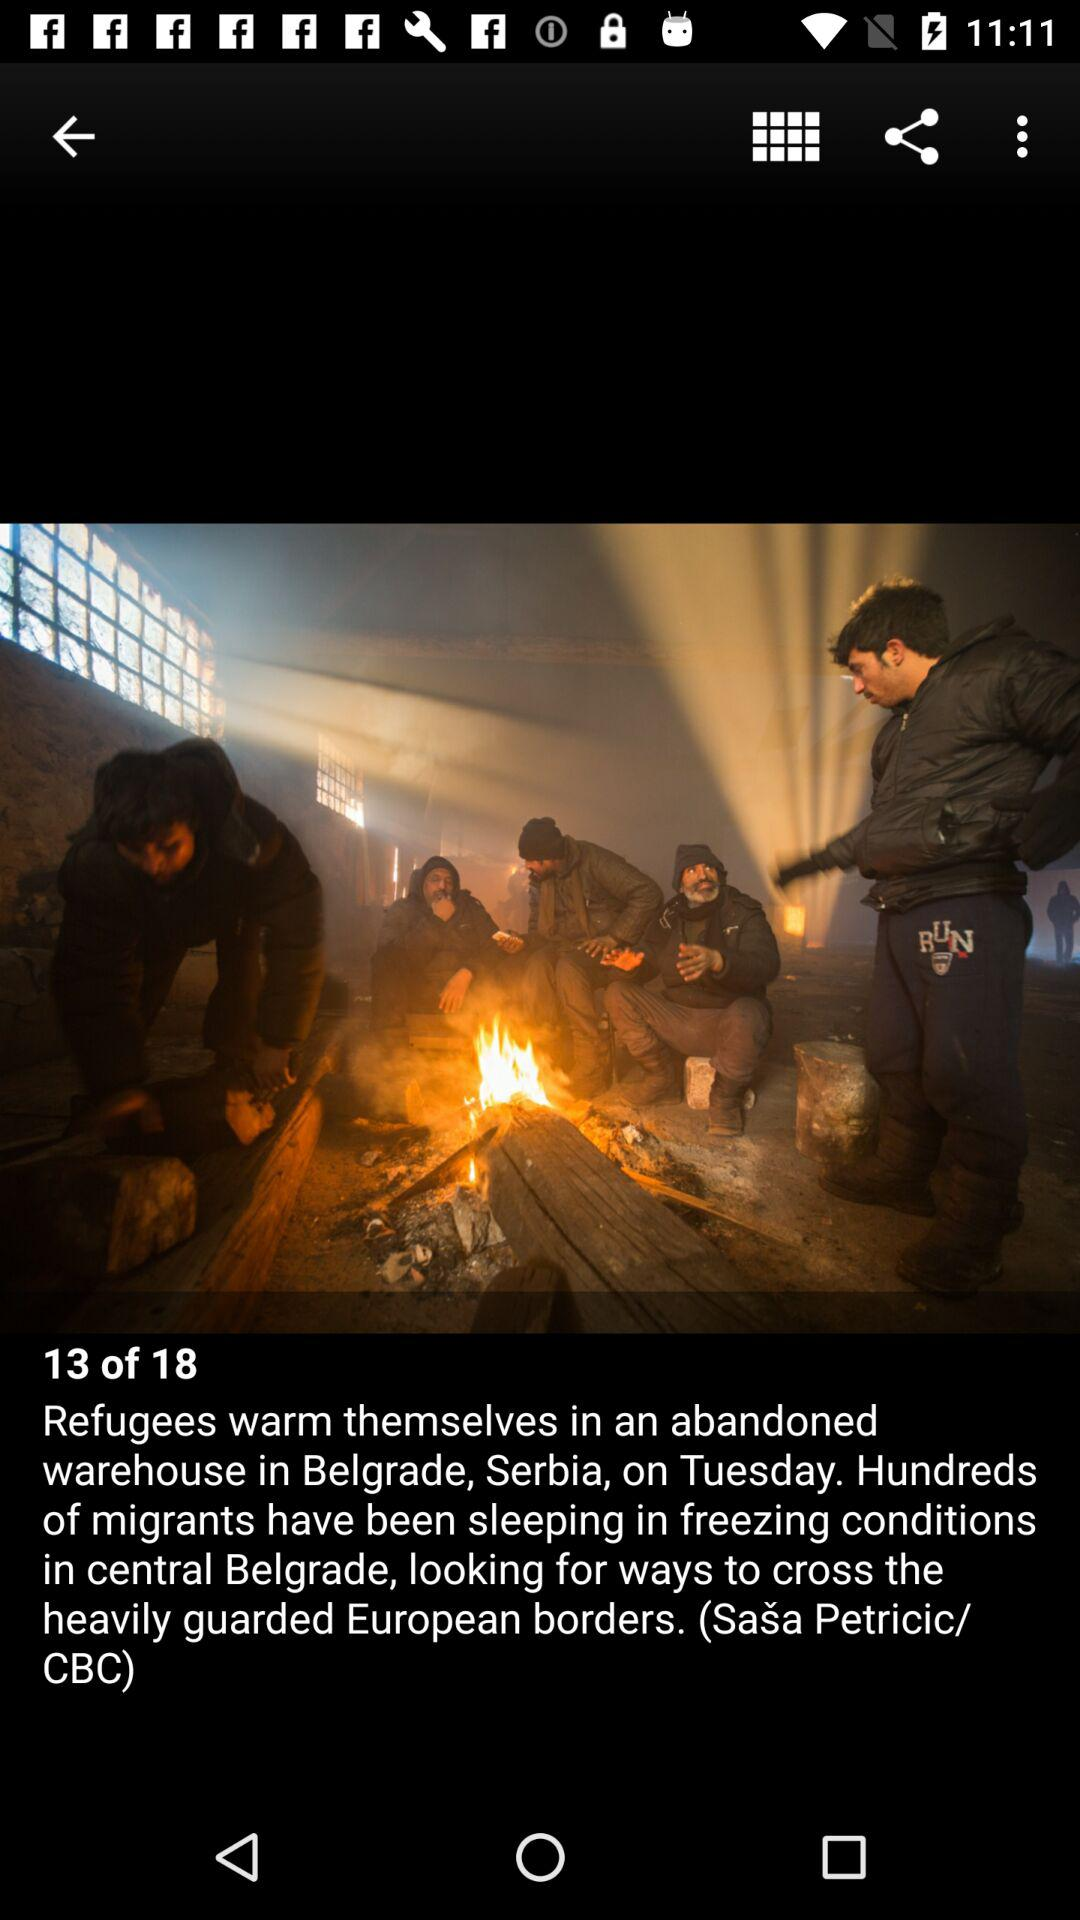Where did the refugees warm themselves? The refugees warm themselves in an abandoned warehouse in Belgrade, Serbia. 